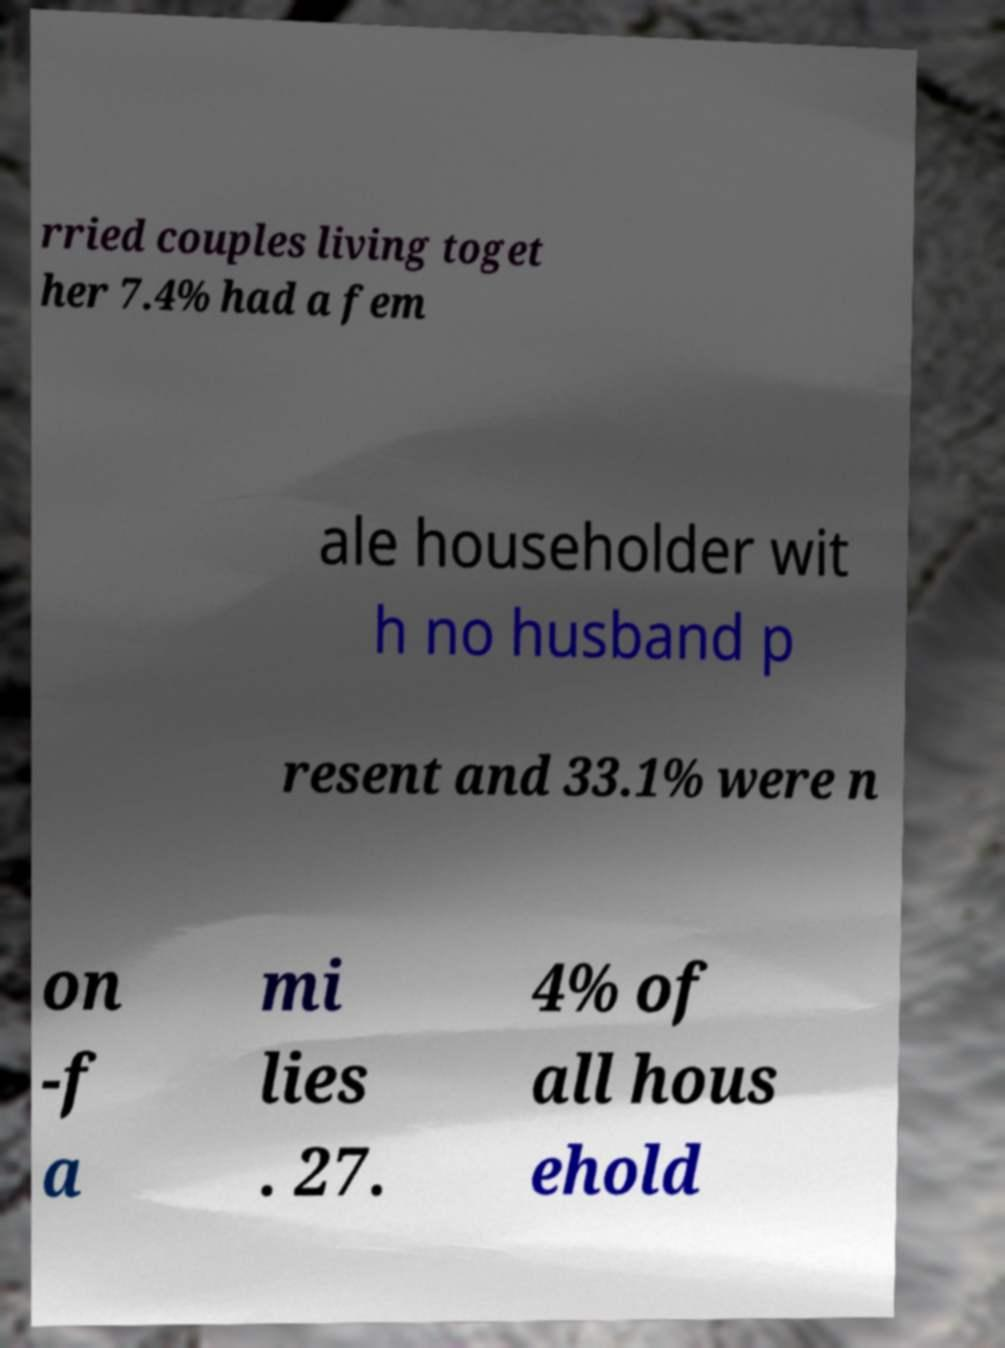Can you read and provide the text displayed in the image?This photo seems to have some interesting text. Can you extract and type it out for me? rried couples living toget her 7.4% had a fem ale householder wit h no husband p resent and 33.1% were n on -f a mi lies . 27. 4% of all hous ehold 